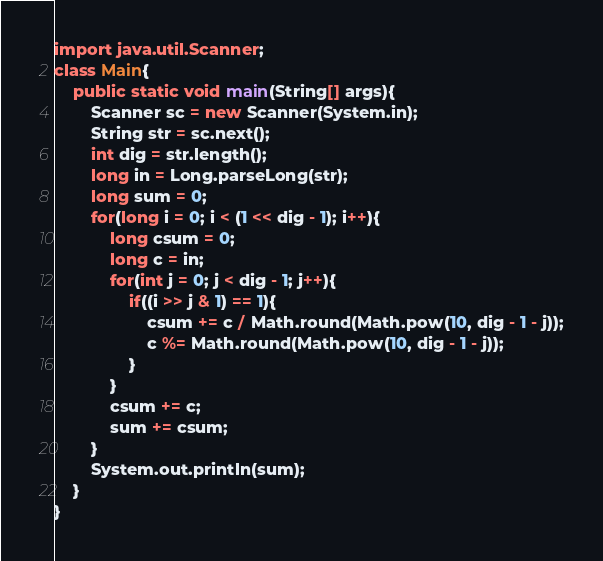<code> <loc_0><loc_0><loc_500><loc_500><_Java_>import java.util.Scanner;
class Main{
    public static void main(String[] args){
        Scanner sc = new Scanner(System.in);
        String str = sc.next();
        int dig = str.length();
        long in = Long.parseLong(str);
        long sum = 0;
        for(long i = 0; i < (1 << dig - 1); i++){
            long csum = 0;
            long c = in;
            for(int j = 0; j < dig - 1; j++){
                if((i >> j & 1) == 1){
                    csum += c / Math.round(Math.pow(10, dig - 1 - j));
                    c %= Math.round(Math.pow(10, dig - 1 - j));
                }
            }
            csum += c;
            sum += csum;
        }
        System.out.println(sum);
    }
}
</code> 